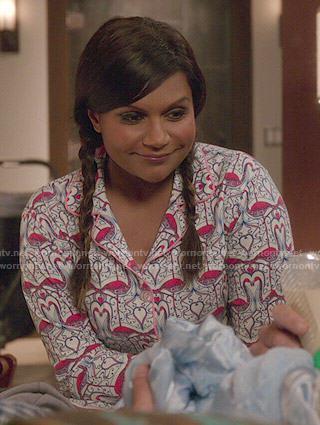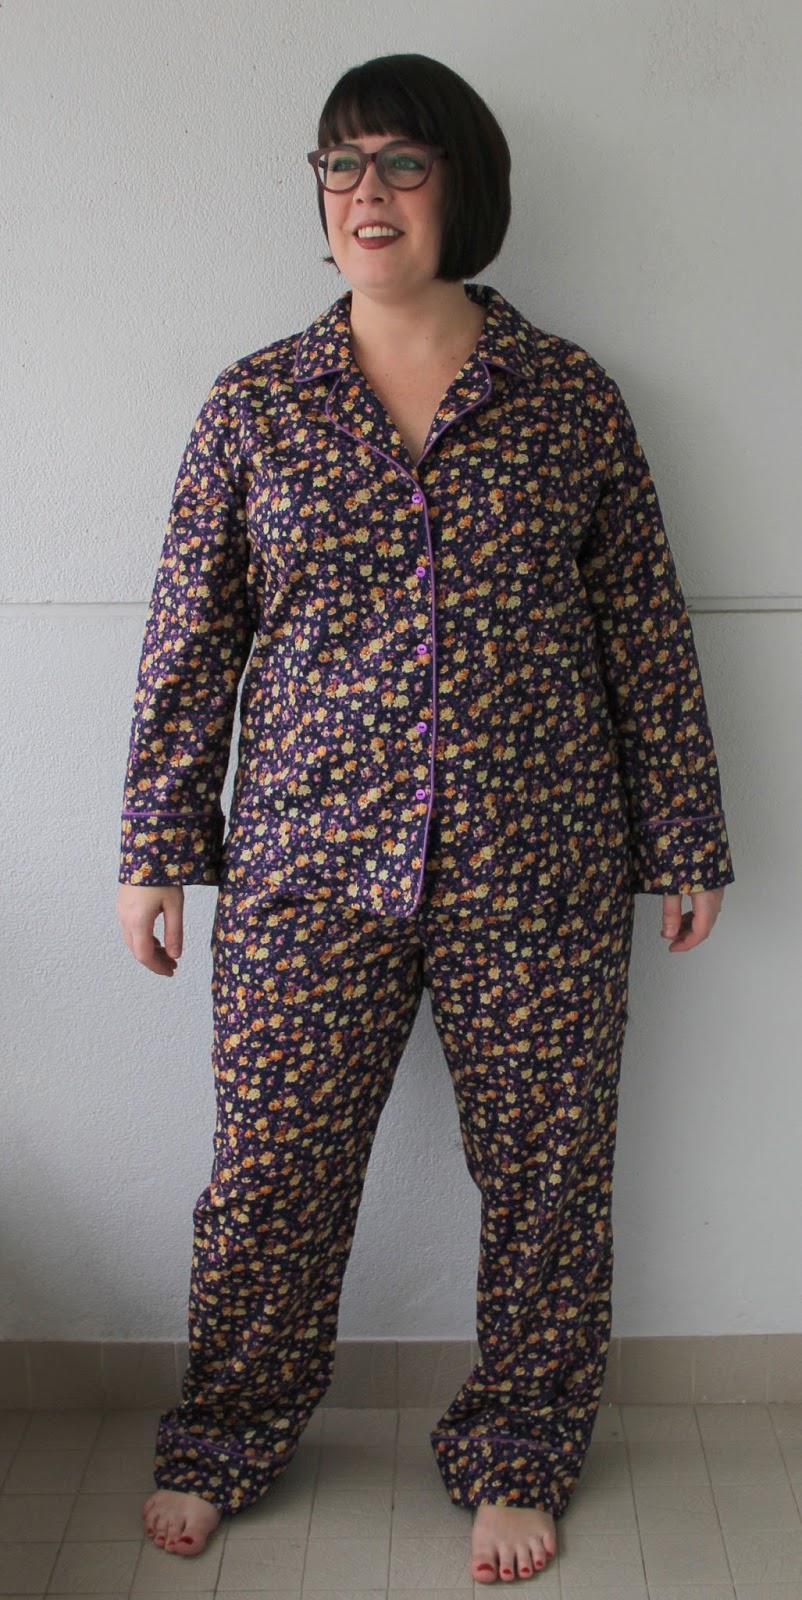The first image is the image on the left, the second image is the image on the right. Examine the images to the left and right. Is the description "The woman in one of the image is wearing a pair of glasses." accurate? Answer yes or no. Yes. 